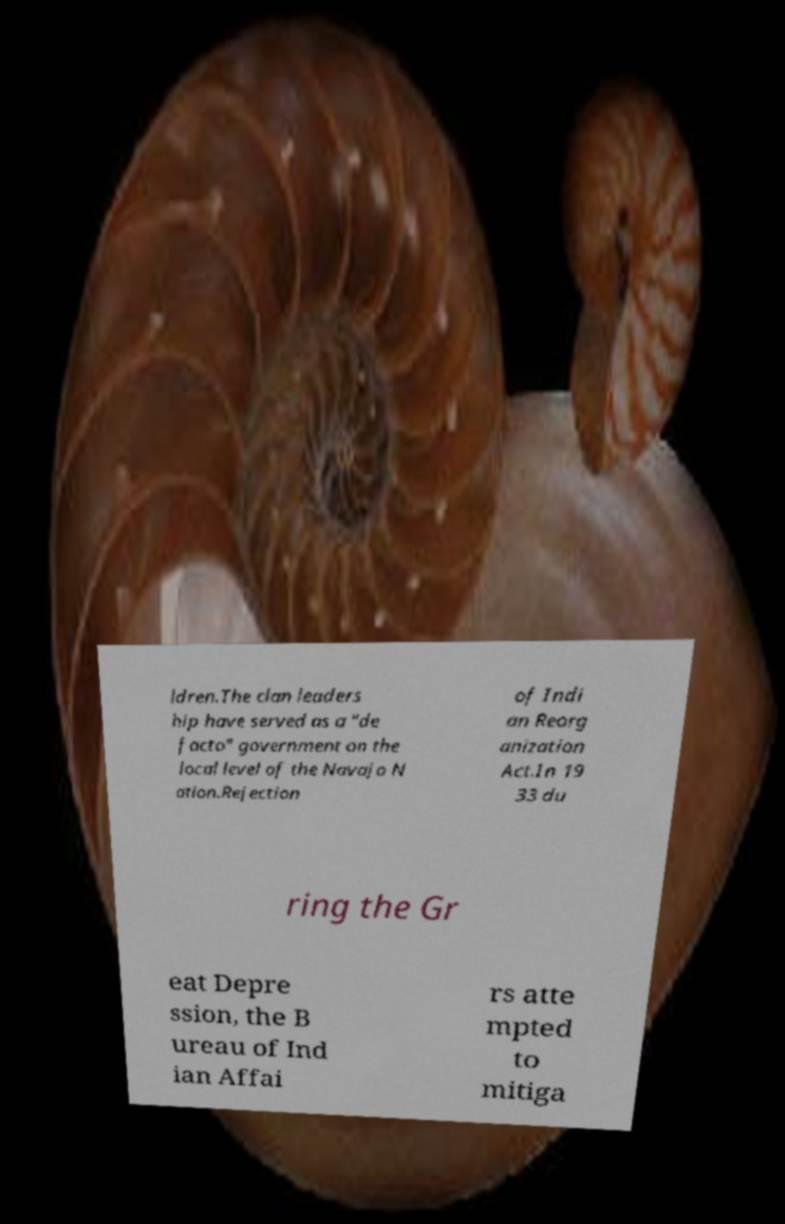Could you extract and type out the text from this image? ldren.The clan leaders hip have served as a "de facto" government on the local level of the Navajo N ation.Rejection of Indi an Reorg anization Act.In 19 33 du ring the Gr eat Depre ssion, the B ureau of Ind ian Affai rs atte mpted to mitiga 